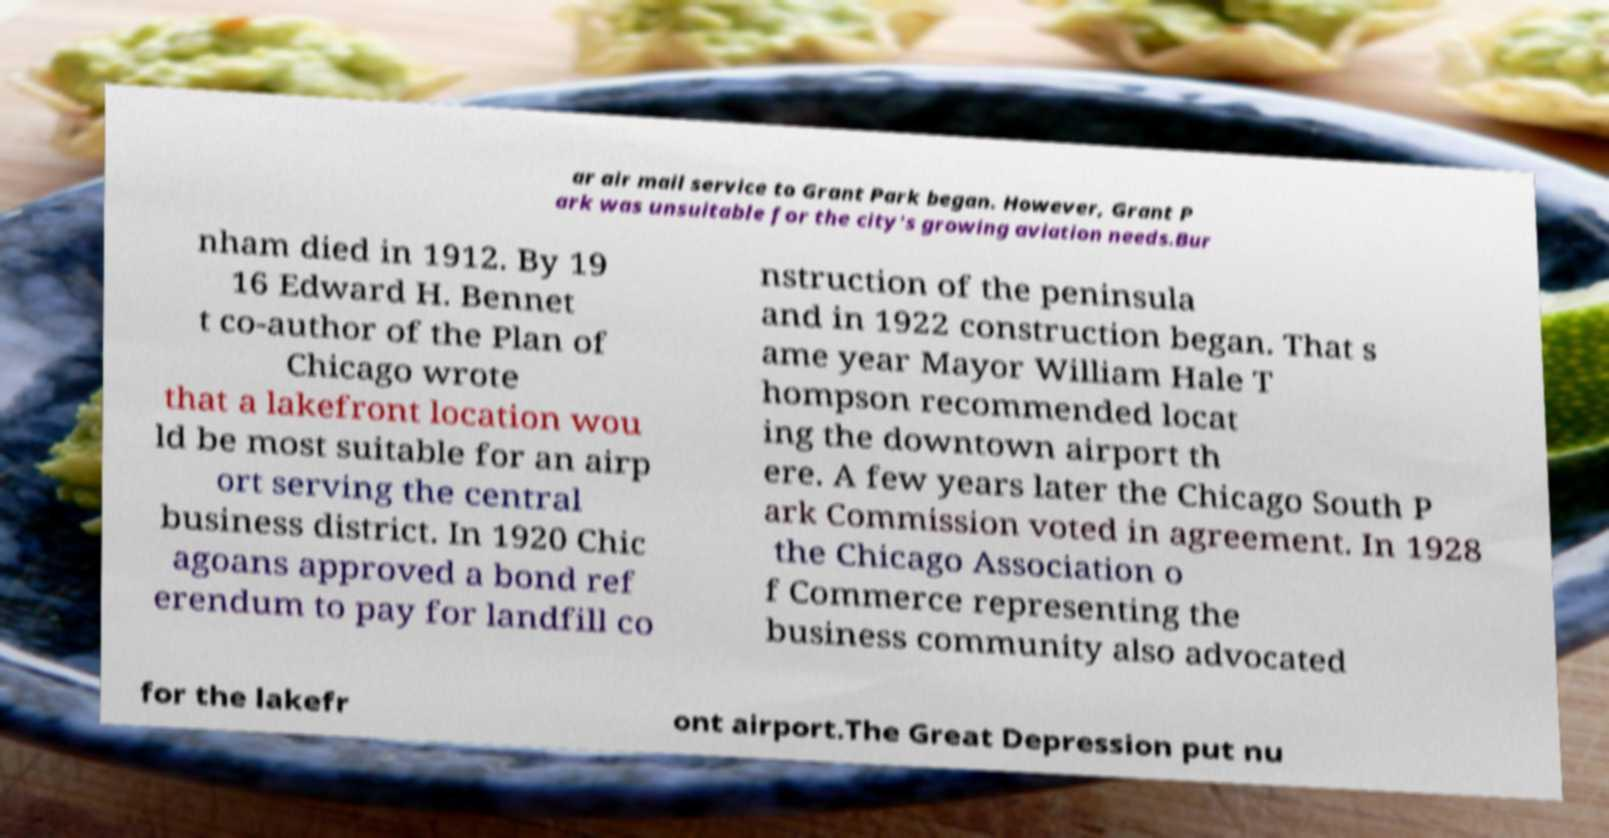What messages or text are displayed in this image? I need them in a readable, typed format. ar air mail service to Grant Park began. However, Grant P ark was unsuitable for the city's growing aviation needs.Bur nham died in 1912. By 19 16 Edward H. Bennet t co-author of the Plan of Chicago wrote that a lakefront location wou ld be most suitable for an airp ort serving the central business district. In 1920 Chic agoans approved a bond ref erendum to pay for landfill co nstruction of the peninsula and in 1922 construction began. That s ame year Mayor William Hale T hompson recommended locat ing the downtown airport th ere. A few years later the Chicago South P ark Commission voted in agreement. In 1928 the Chicago Association o f Commerce representing the business community also advocated for the lakefr ont airport.The Great Depression put nu 